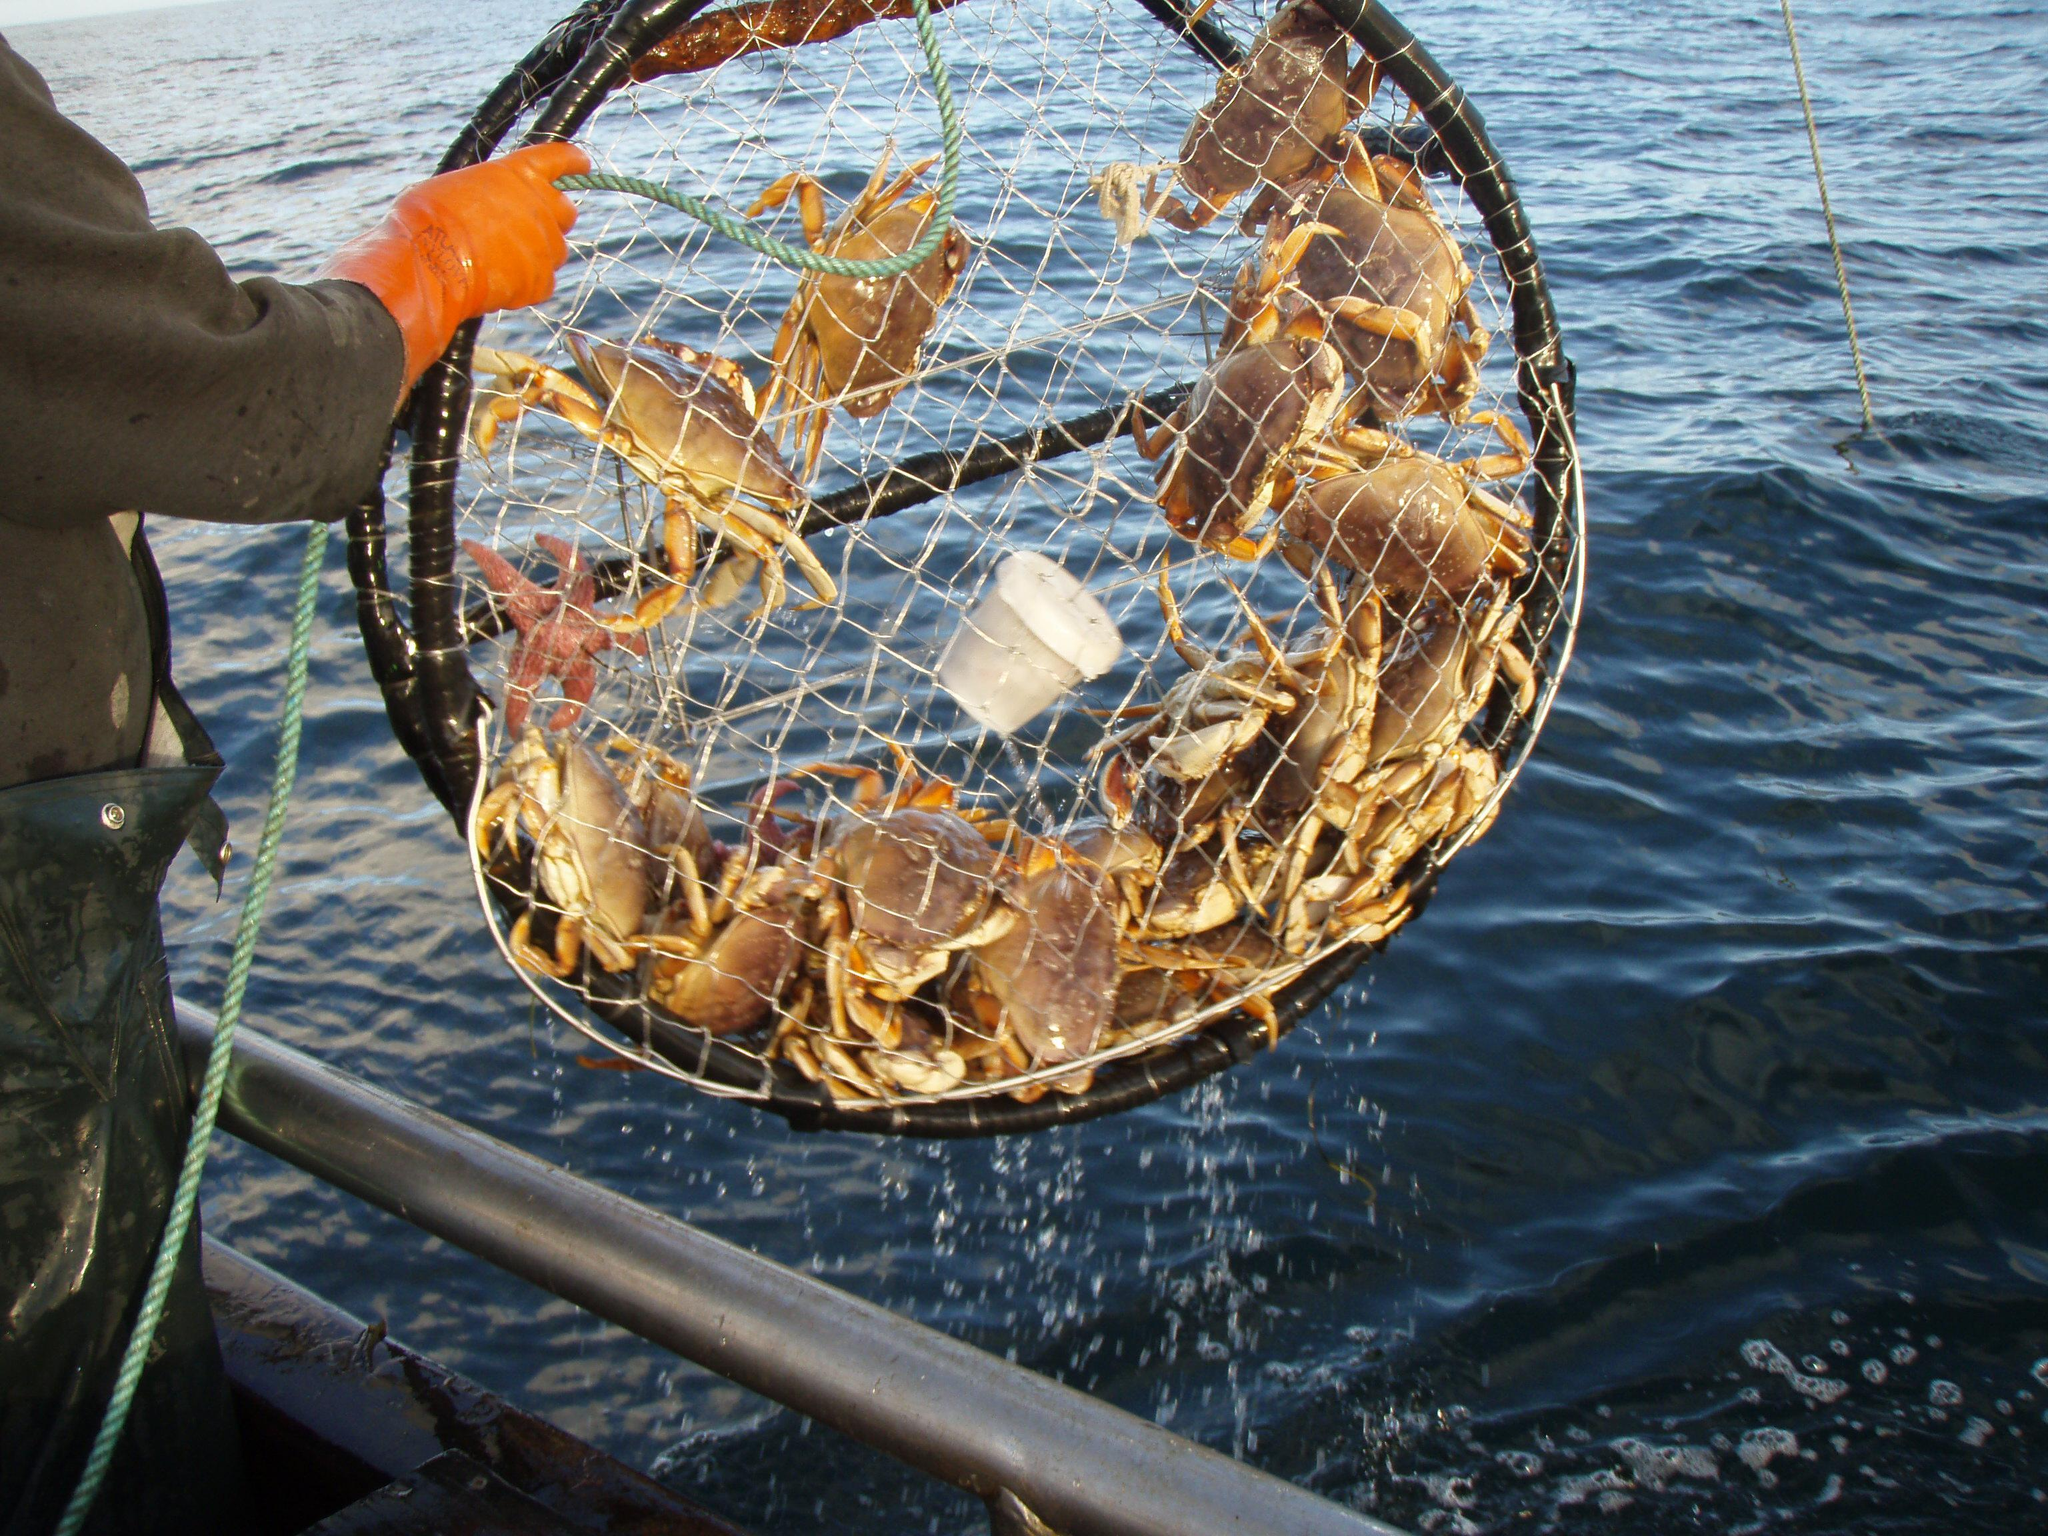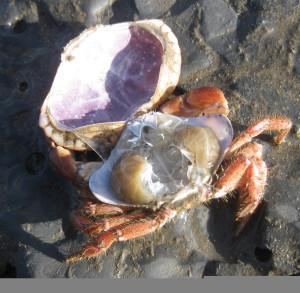The first image is the image on the left, the second image is the image on the right. Analyze the images presented: Is the assertion "Some of the crabs are in a net." valid? Answer yes or no. Yes. 